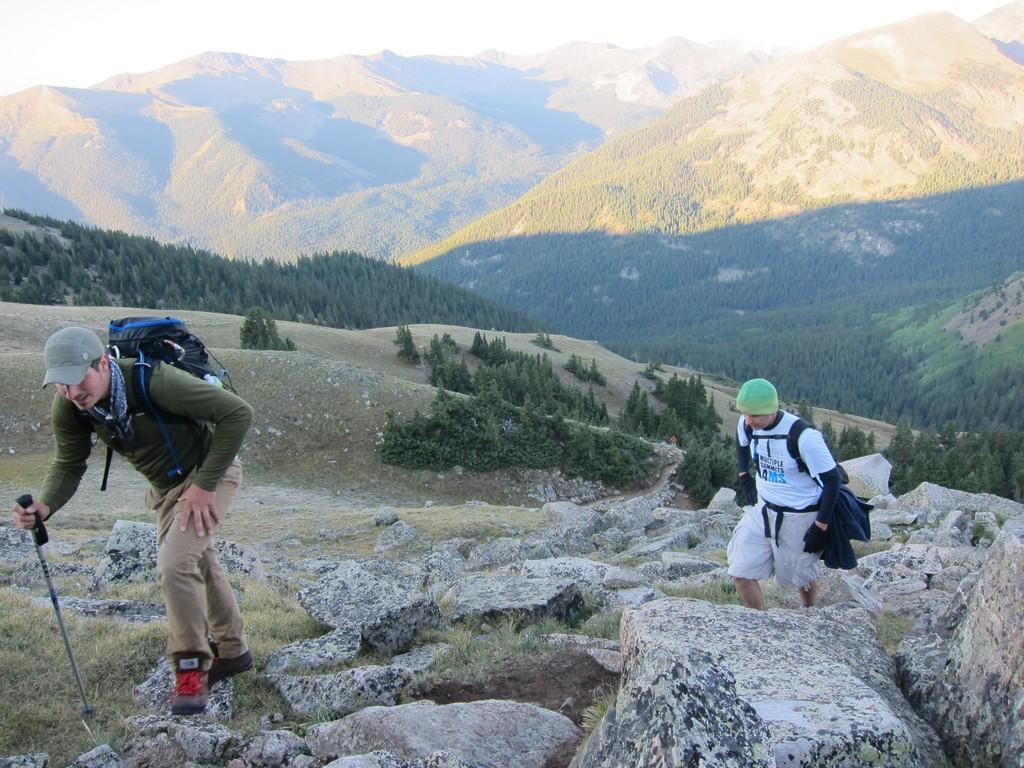How many people are in the image? There are two persons in the image. What is one person wearing? One person is wearing a cap. What is the person wearing a cap carrying? The person wearing a cap is carrying a backpack. What type of natural environment is visible in the image? There are trees and a mountain in the background of the image. What part of the natural environment is visible in the image? The sky is visible in the image. What type of star can be seen expanding in the image? There is no star present in the image, and therefore no such expansion can be observed. 